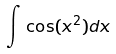Convert formula to latex. <formula><loc_0><loc_0><loc_500><loc_500>\int \cos ( x ^ { 2 } ) d x</formula> 